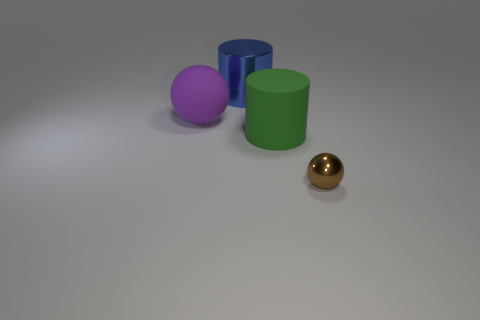Add 1 green rubber cylinders. How many objects exist? 5 Subtract all purple spheres. How many spheres are left? 1 Subtract 1 spheres. How many spheres are left? 1 Subtract 0 red cubes. How many objects are left? 4 Subtract all purple spheres. Subtract all yellow blocks. How many spheres are left? 1 Subtract all green spheres. Subtract all big blue metal cylinders. How many objects are left? 3 Add 2 big things. How many big things are left? 5 Add 1 big purple things. How many big purple things exist? 2 